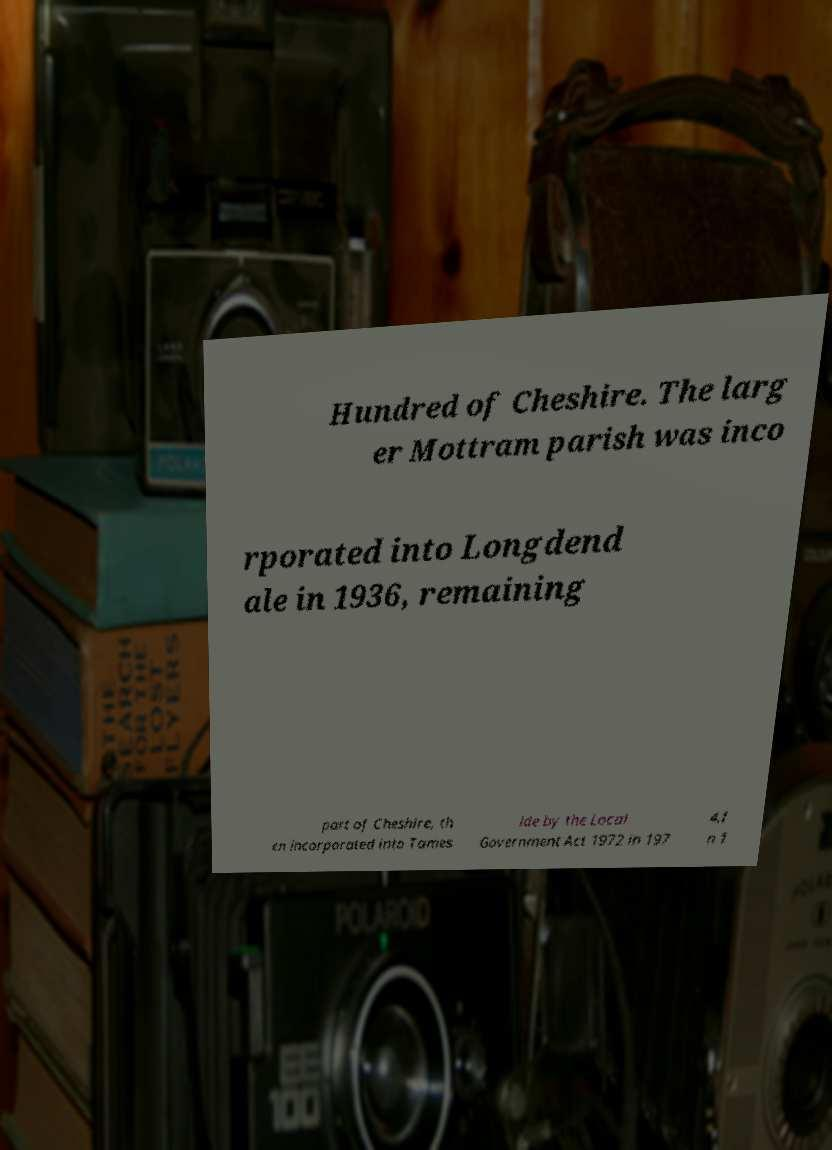Please identify and transcribe the text found in this image. Hundred of Cheshire. The larg er Mottram parish was inco rporated into Longdend ale in 1936, remaining part of Cheshire, th en incorporated into Tames ide by the Local Government Act 1972 in 197 4.I n 1 